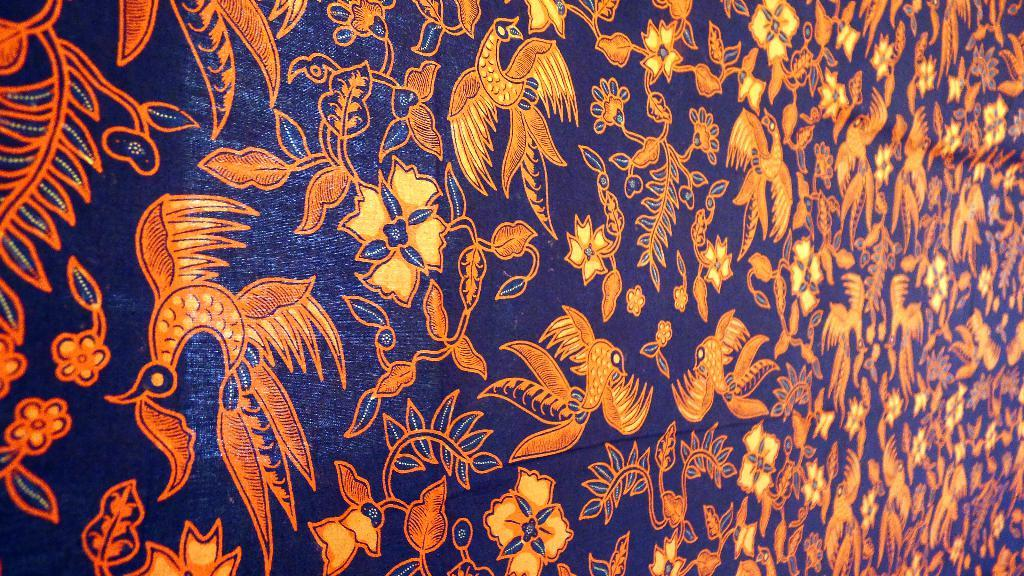What is the main color of the design in the image? The main color of the design in the image is orange. What is the background color of the design in the image? The orange design is on a blue surface. How does the rifle affect the orange design in the image? There is no rifle present in the image, so it cannot affect the orange design. 